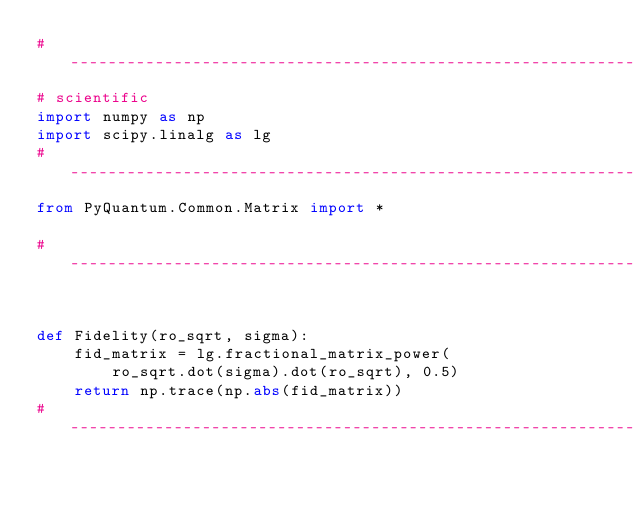Convert code to text. <code><loc_0><loc_0><loc_500><loc_500><_Python_># -------------------------------------------------------------------------------------------------
# scientific
import numpy as np
import scipy.linalg as lg
# -------------------------------------------------------------------------------------------------
from PyQuantum.Common.Matrix import *

# -------------------------------------------------------------------------------------------------


def Fidelity(ro_sqrt, sigma):
    fid_matrix = lg.fractional_matrix_power(
        ro_sqrt.dot(sigma).dot(ro_sqrt), 0.5)
    return np.trace(np.abs(fid_matrix))
# -------------------------------------------------------------------------------------------------
</code> 